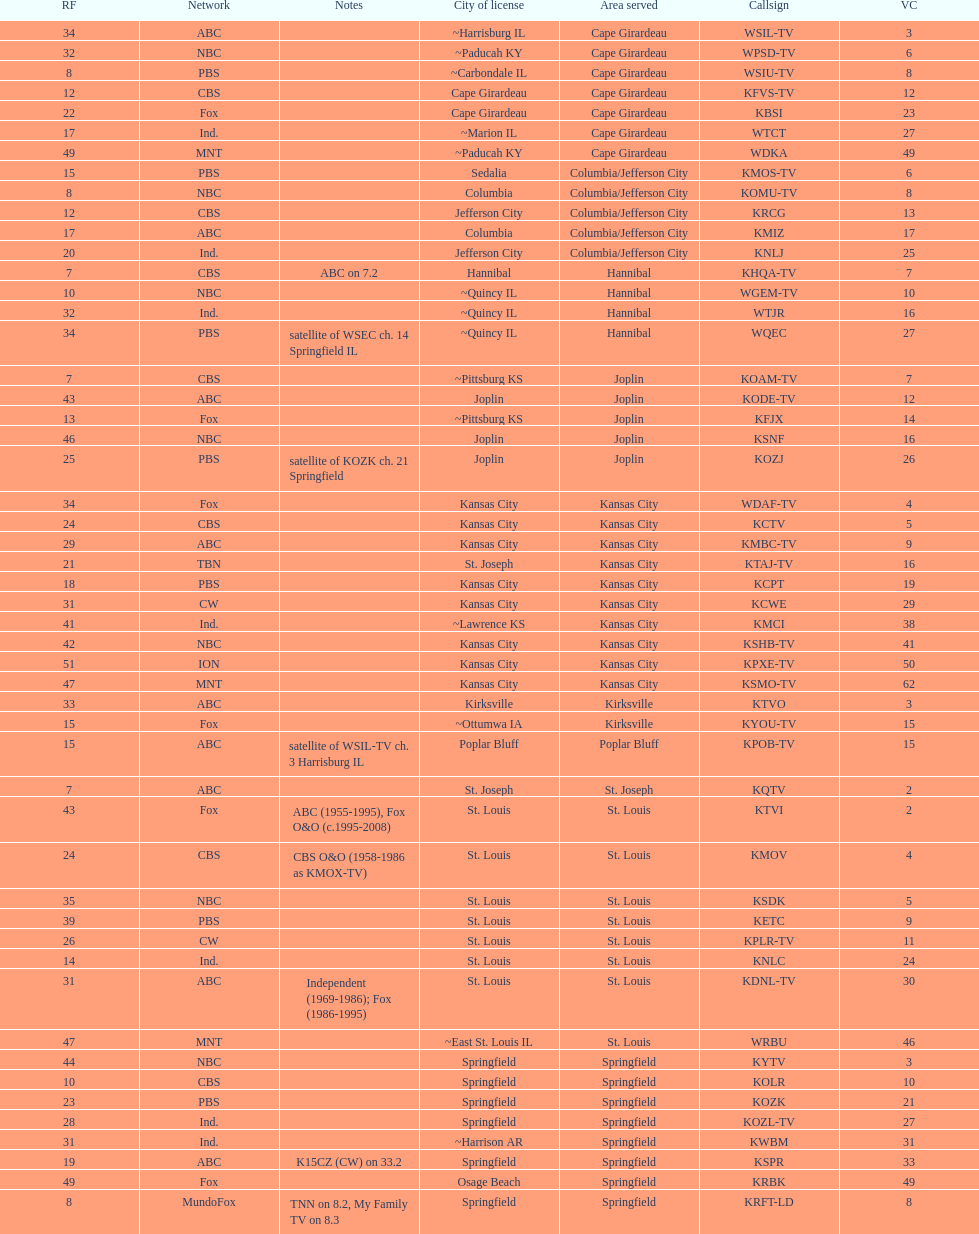Which station is licensed in the same city as koam-tv? KFJX. 